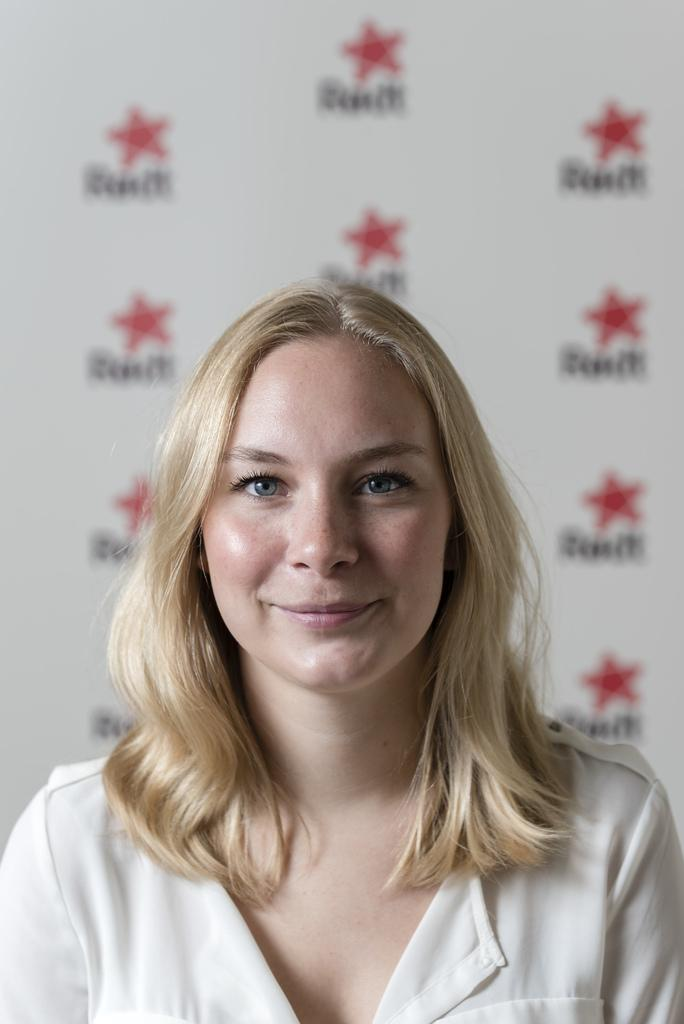Who is present in the image? There is a woman in the image. What is the woman's expression? The woman is smiling. What can be seen in the background of the image? There is a banner in the background of the image. What is on the banner? The banner has logos and letters on it. How many fairies are flying around the woman in the image? There are no fairies present in the image. What is the woman arguing about with the person off-camera? There is no argument or person off-camera mentioned in the image, and the woman's expression is a smile. 